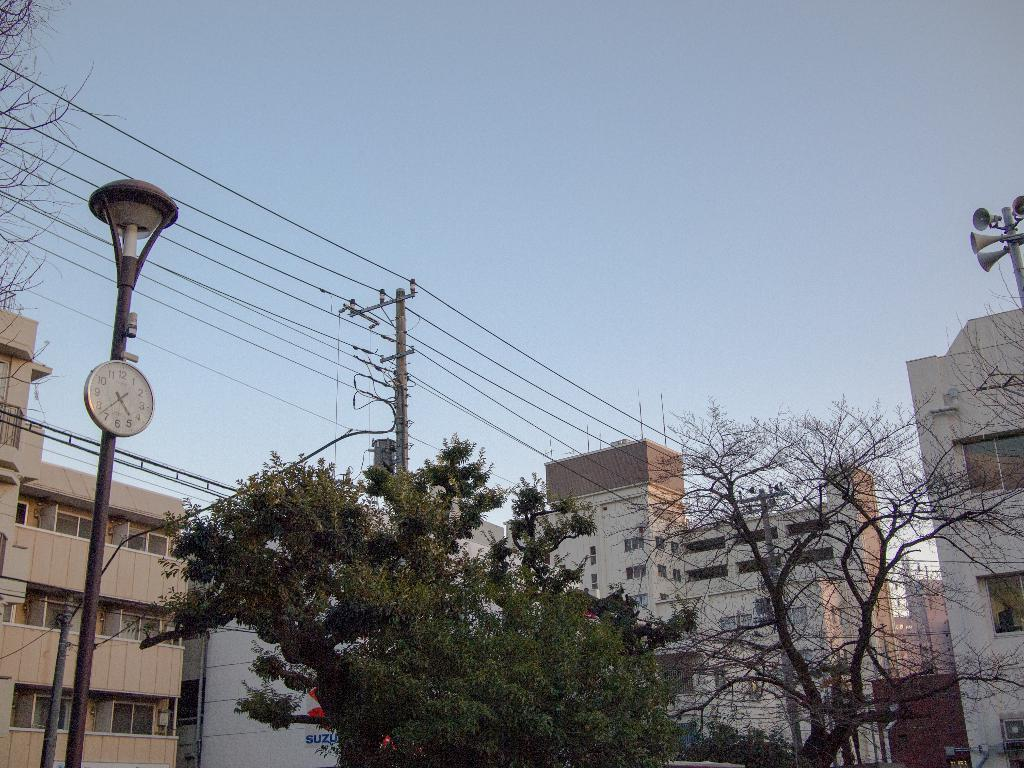What type of structures can be seen in the image? There are buildings in the image. What architectural features are present on the buildings? There are windows visible on the buildings. What type of vegetation is present in the image? There are trees in the image. What type of street furniture can be seen in the image? There are poles and a wall clock in the image. What type of audio equipment is present in the image? There are speakers in the image. What type of electrical infrastructure is present in the image? There are electrical poles, wires, and a transformer in the image. What part of the natural environment is visible in the image? The sky is visible in the image. How many crows are sitting on the transformer in the image? There are no crows present in the image. What is the value of the transformer in the image? The value of the transformer cannot be determined from the image. 